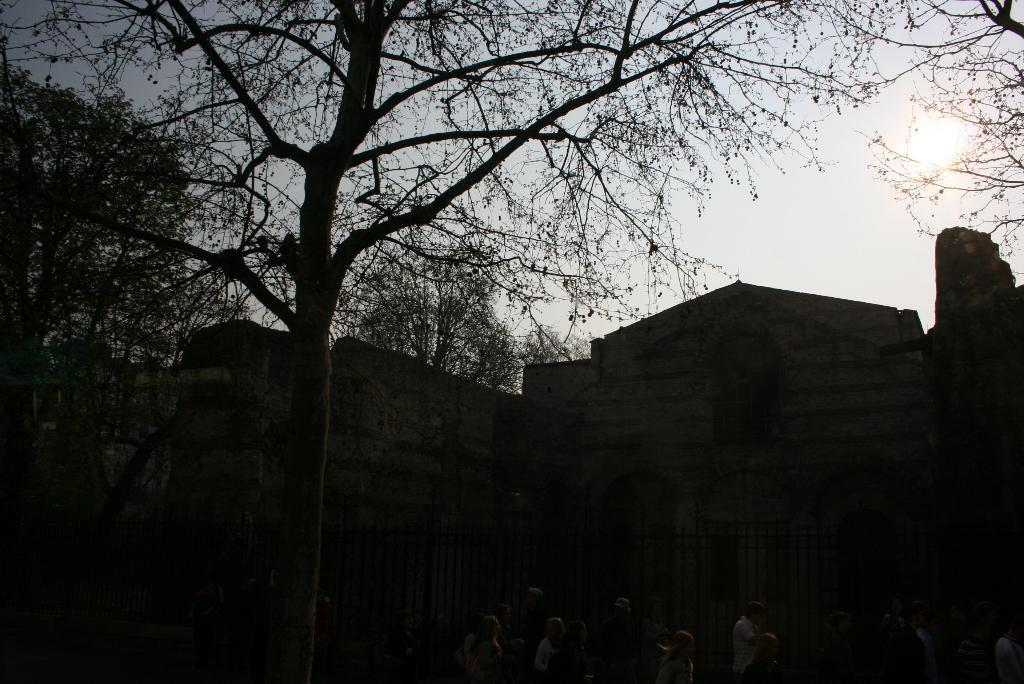What type of natural elements can be seen in the image? There are trees in the image. What man-made structure is present in the image? There is a wall in the image. What else can be found on the ground in the image? There are other objects on the ground. What is visible in the background of the image? The sky is visible in the background of the image. Can the sun be seen in the image? Yes, the sun is observable in the sky. How many fingers can be seen pointing at the sun in the image? There are no fingers or people pointing at the sun in the image. What type of gate is present in the image? There is no gate present in the image. 